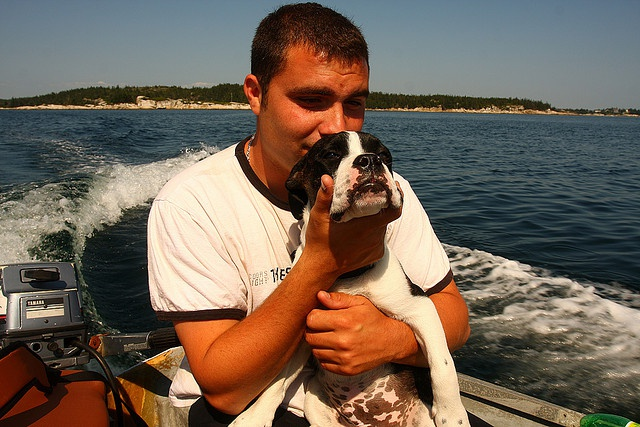Describe the objects in this image and their specific colors. I can see people in gray, beige, red, black, and maroon tones, boat in gray, black, maroon, and tan tones, and dog in gray, black, tan, maroon, and beige tones in this image. 